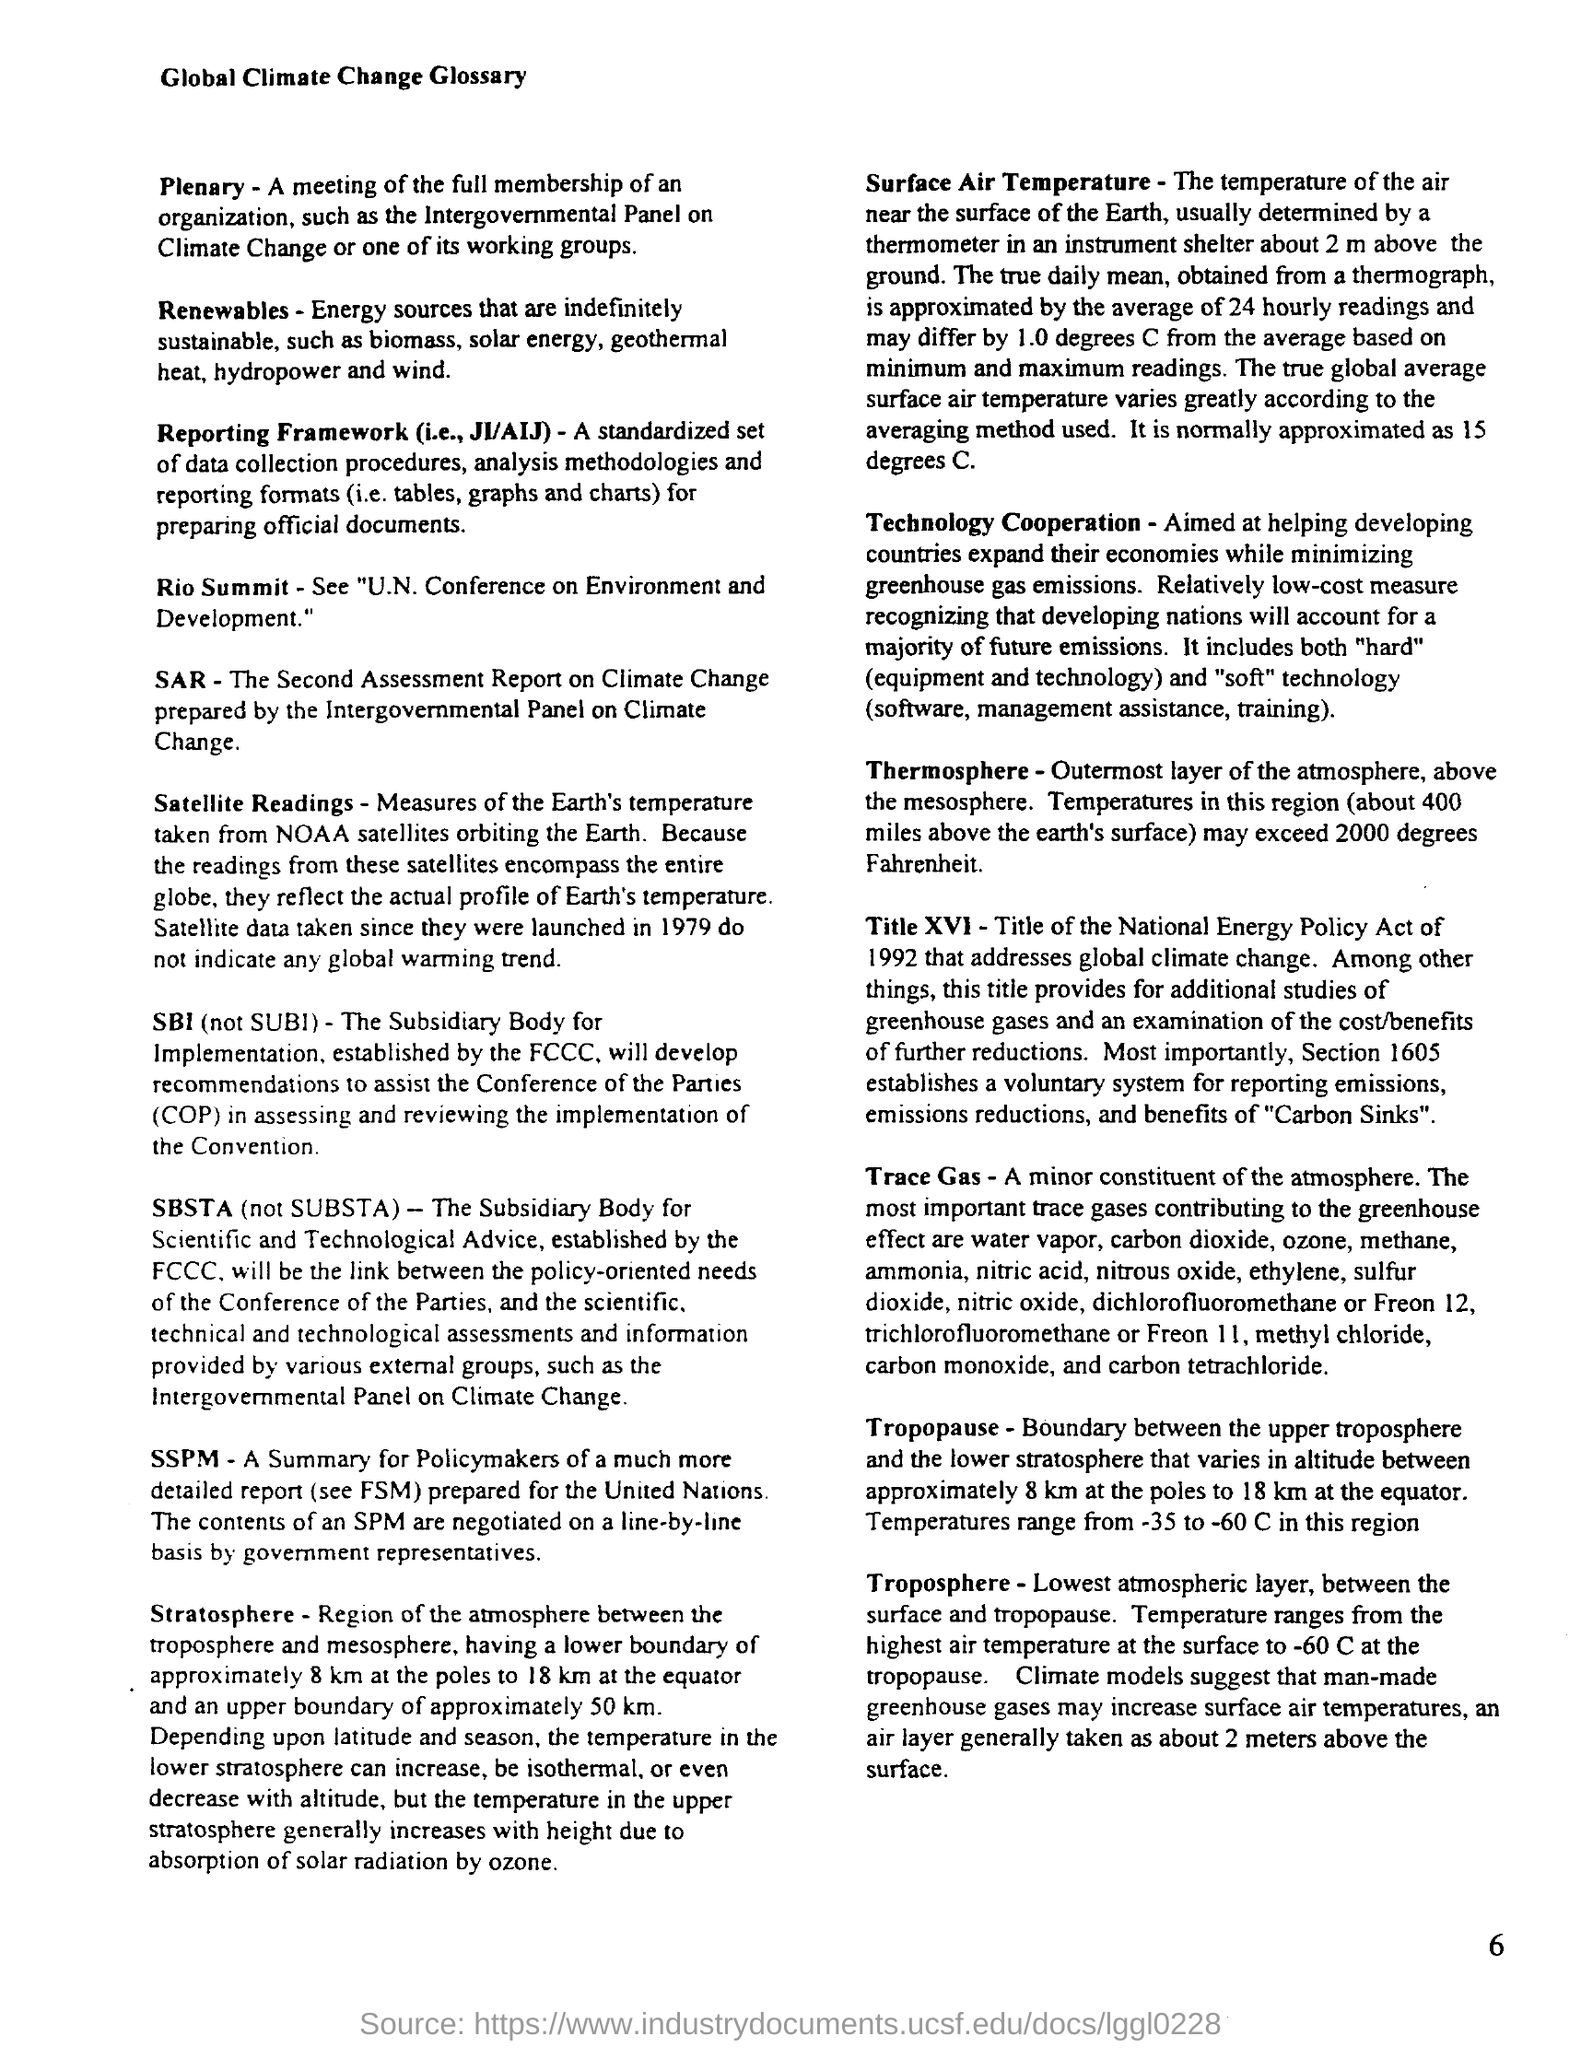What is the document about?
Your answer should be very brief. Global Climate Change Glossary. What are the energy sources that are indefinitely sustainable called?
Offer a terse response. Renewables. What is the true global average surface air temperature approximated as?
Your answer should be very brief. 15 degrees C. What does Title XVI address?
Your answer should be very brief. Global climate change. 